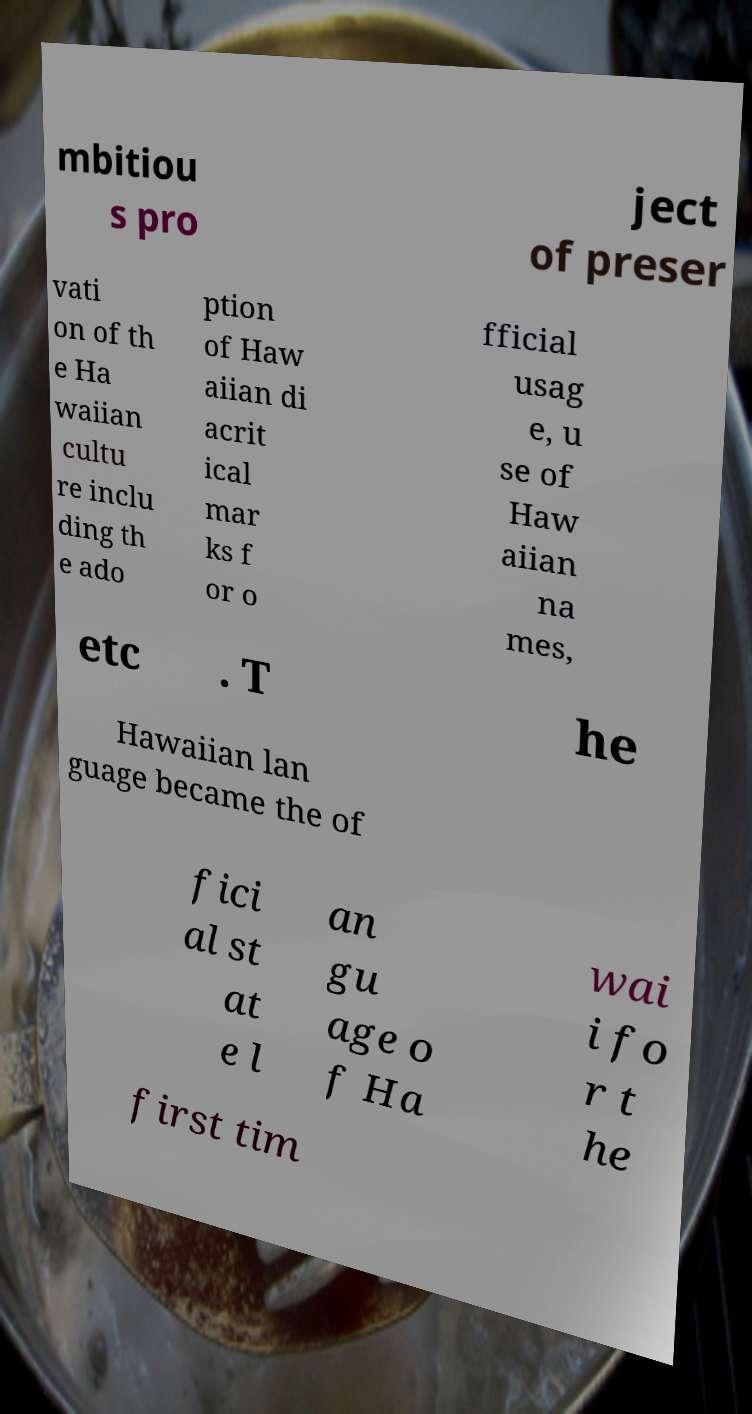Please identify and transcribe the text found in this image. mbitiou s pro ject of preser vati on of th e Ha waiian cultu re inclu ding th e ado ption of Haw aiian di acrit ical mar ks f or o fficial usag e, u se of Haw aiian na mes, etc . T he Hawaiian lan guage became the of fici al st at e l an gu age o f Ha wai i fo r t he first tim 